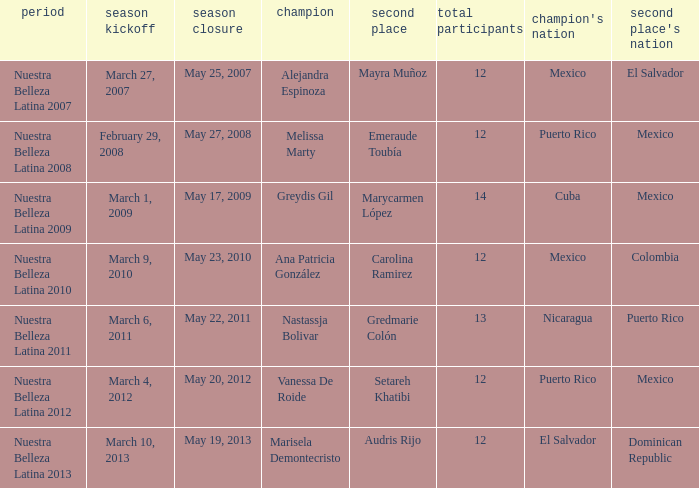How many contestants were there on March 1, 2009 during the season premiere? 14.0. 